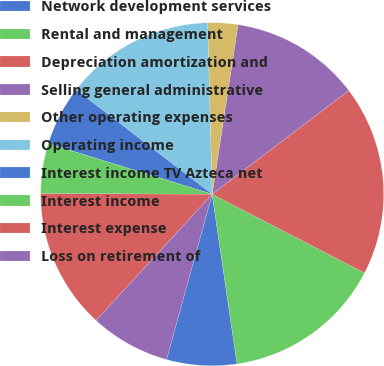<chart> <loc_0><loc_0><loc_500><loc_500><pie_chart><fcel>Network development services<fcel>Rental and management<fcel>Depreciation amortization and<fcel>Selling general administrative<fcel>Other operating expenses<fcel>Operating income<fcel>Interest income TV Azteca net<fcel>Interest income<fcel>Interest expense<fcel>Loss on retirement of<nl><fcel>6.6%<fcel>15.09%<fcel>17.92%<fcel>12.26%<fcel>2.83%<fcel>14.15%<fcel>5.66%<fcel>4.72%<fcel>13.21%<fcel>7.55%<nl></chart> 